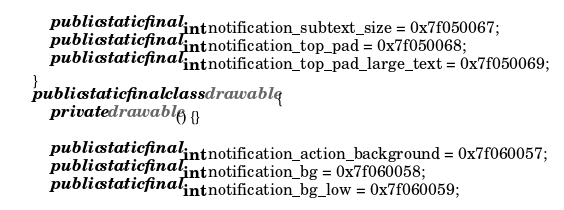Convert code to text. <code><loc_0><loc_0><loc_500><loc_500><_Java_>        public static final int notification_subtext_size = 0x7f050067;
        public static final int notification_top_pad = 0x7f050068;
        public static final int notification_top_pad_large_text = 0x7f050069;
    }
    public static final class drawable {
        private drawable() {}

        public static final int notification_action_background = 0x7f060057;
        public static final int notification_bg = 0x7f060058;
        public static final int notification_bg_low = 0x7f060059;</code> 